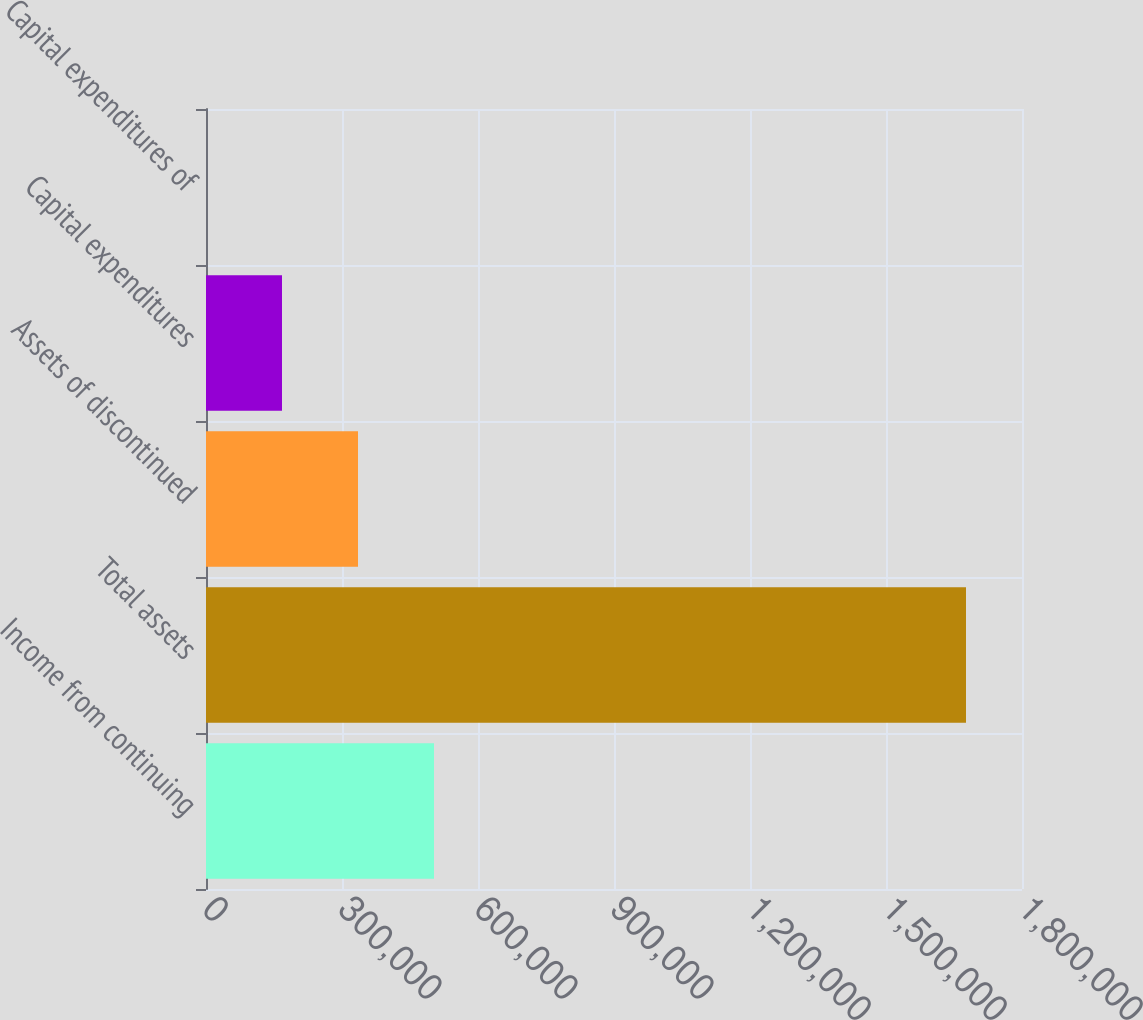Convert chart. <chart><loc_0><loc_0><loc_500><loc_500><bar_chart><fcel>Income from continuing<fcel>Total assets<fcel>Assets of discontinued<fcel>Capital expenditures<fcel>Capital expenditures of<nl><fcel>502939<fcel>1.67646e+06<fcel>335292<fcel>167646<fcel>0.34<nl></chart> 